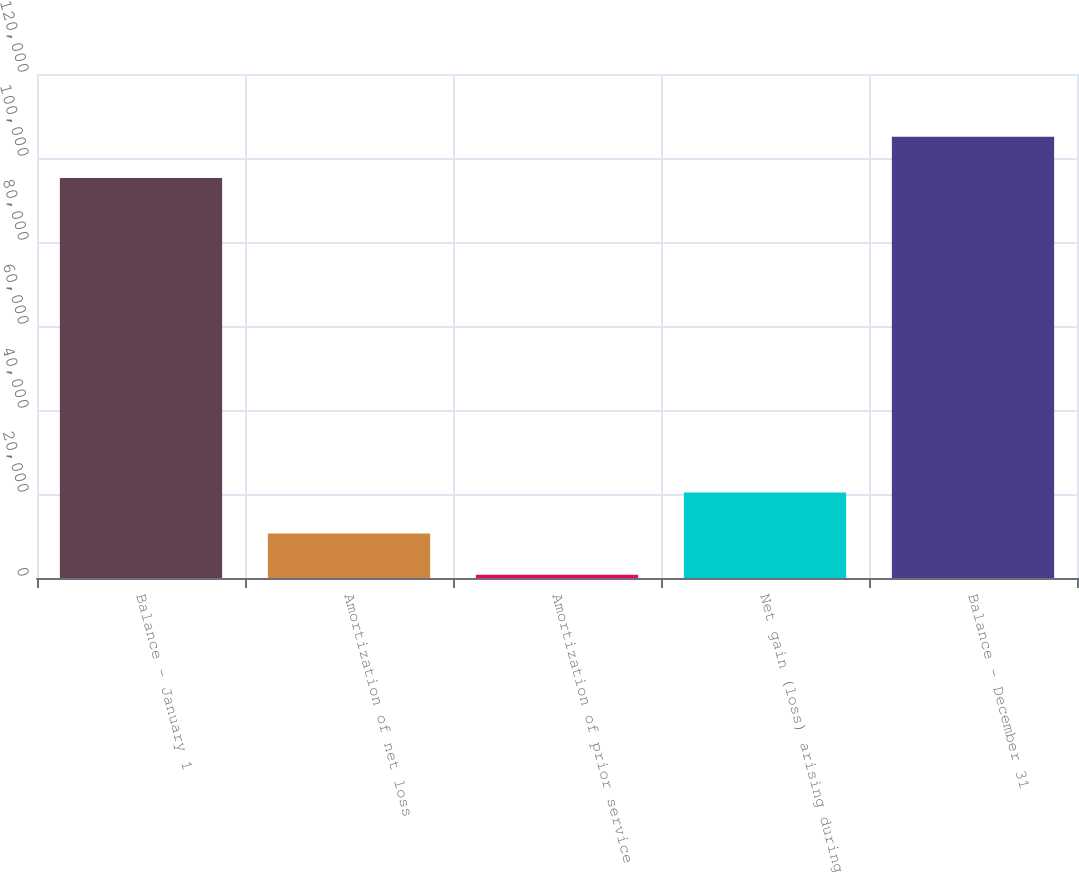Convert chart. <chart><loc_0><loc_0><loc_500><loc_500><bar_chart><fcel>Balance - January 1<fcel>Amortization of net loss<fcel>Amortization of prior service<fcel>Net gain (loss) arising during<fcel>Balance - December 31<nl><fcel>95258<fcel>10568.4<fcel>771<fcel>20365.8<fcel>105055<nl></chart> 